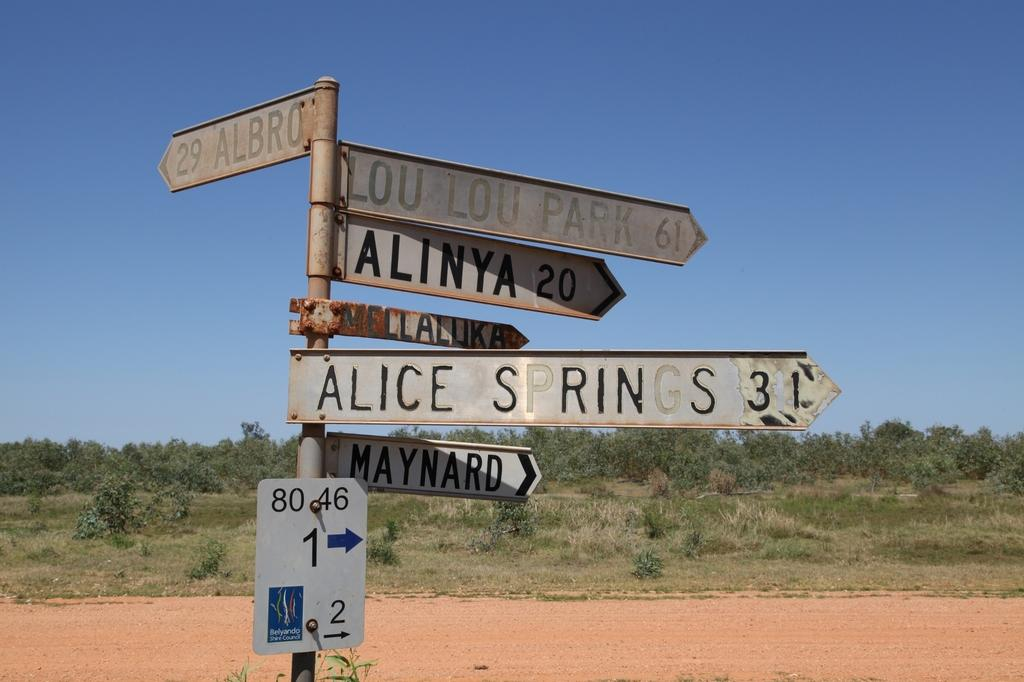<image>
Share a concise interpretation of the image provided. A sign indicates that Alinya is 20 miles away while Lou Lou Park is 61 miles away. 